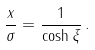Convert formula to latex. <formula><loc_0><loc_0><loc_500><loc_500>\frac { x } { \sigma } = \frac { 1 } { \cosh \xi } \, .</formula> 